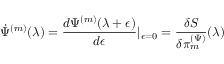Convert formula to latex. <formula><loc_0><loc_0><loc_500><loc_500>\dot { \Psi } ^ { ( m ) } ( \lambda ) = \frac { d \Psi ^ { ( m ) } ( \lambda + \epsilon ) } { d \epsilon } | _ { \epsilon = 0 } = \frac { \delta S } { \delta \pi _ { m } ^ { ( \Psi ) } } ( \lambda )</formula> 